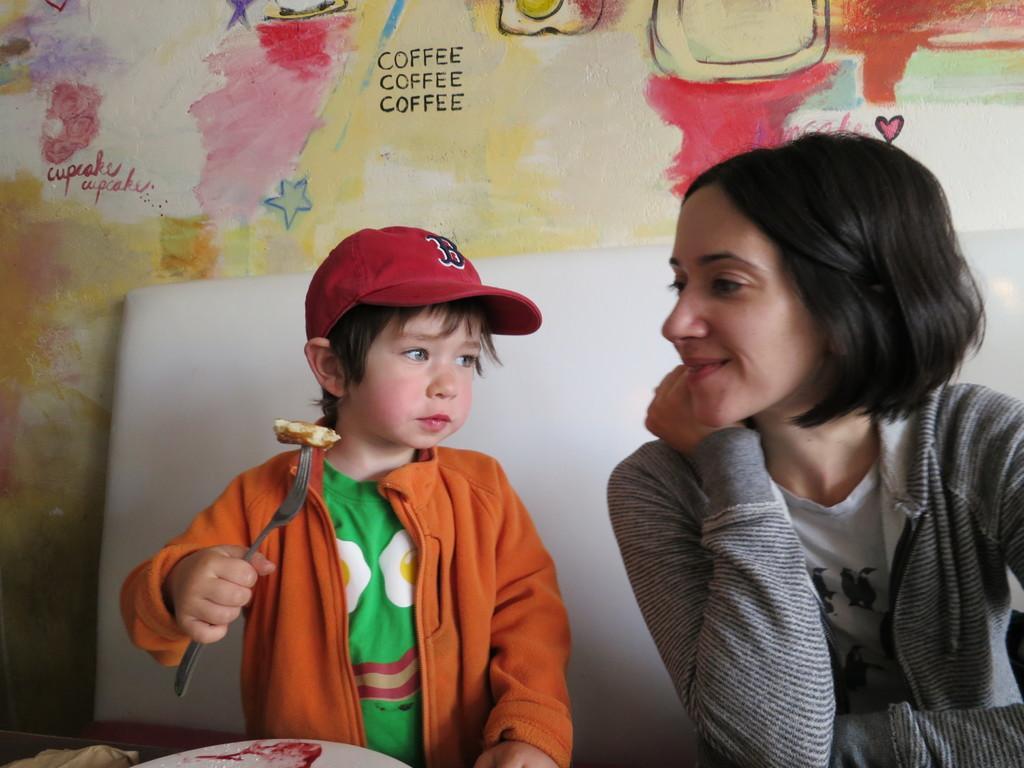How would you summarize this image in a sentence or two? In this image there is a kid sitting in a sofa is holding a fork in his hand with some food item to it, beside the kid there is a woman sitting, in front of the kid there is a plate and some object on the table, behind the kid there is a wall. 